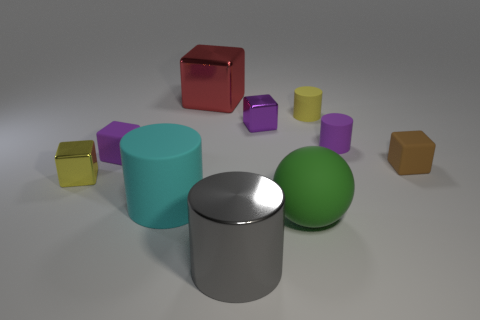There is a small purple thing that is the same shape as the cyan thing; what material is it?
Your answer should be very brief. Rubber. What is the color of the small matte cube that is on the right side of the large green matte object?
Give a very brief answer. Brown. How big is the purple matte cylinder?
Offer a terse response. Small. Does the green matte ball have the same size as the matte cylinder in front of the small yellow metal object?
Provide a succinct answer. Yes. There is a small rubber cylinder behind the tiny purple thing behind the purple matte thing that is right of the red metal thing; what is its color?
Ensure brevity in your answer.  Yellow. Is the material of the small yellow thing that is in front of the small brown rubber thing the same as the yellow cylinder?
Give a very brief answer. No. How many other things are there of the same material as the cyan cylinder?
Provide a short and direct response. 5. There is a cyan cylinder that is the same size as the green object; what material is it?
Provide a succinct answer. Rubber. There is a big metal object that is behind the yellow matte thing; is it the same shape as the small thing right of the small purple rubber cylinder?
Your response must be concise. Yes. There is a cyan thing that is the same size as the green object; what shape is it?
Your answer should be very brief. Cylinder. 